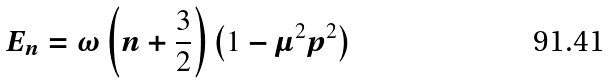<formula> <loc_0><loc_0><loc_500><loc_500>E _ { n } = \omega \left ( n + \frac { 3 } { 2 } \right ) \left ( 1 - \mu ^ { 2 } p ^ { 2 } \right )</formula> 